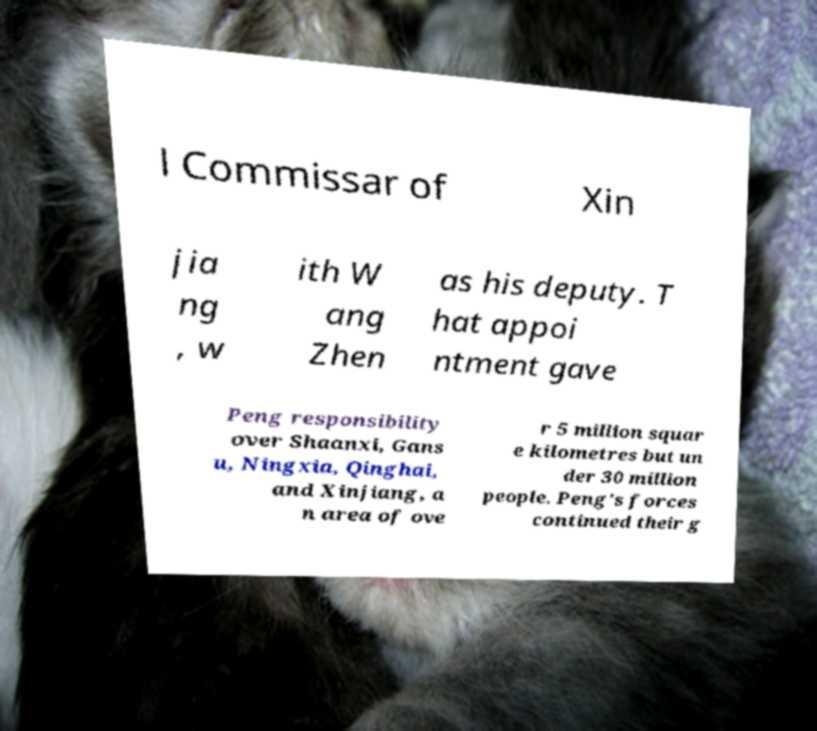Could you extract and type out the text from this image? l Commissar of Xin jia ng , w ith W ang Zhen as his deputy. T hat appoi ntment gave Peng responsibility over Shaanxi, Gans u, Ningxia, Qinghai, and Xinjiang, a n area of ove r 5 million squar e kilometres but un der 30 million people. Peng's forces continued their g 